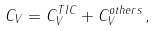Convert formula to latex. <formula><loc_0><loc_0><loc_500><loc_500>C _ { V } = C _ { V } ^ { T I C } + C _ { V } ^ { o t h e r s } \, ,</formula> 